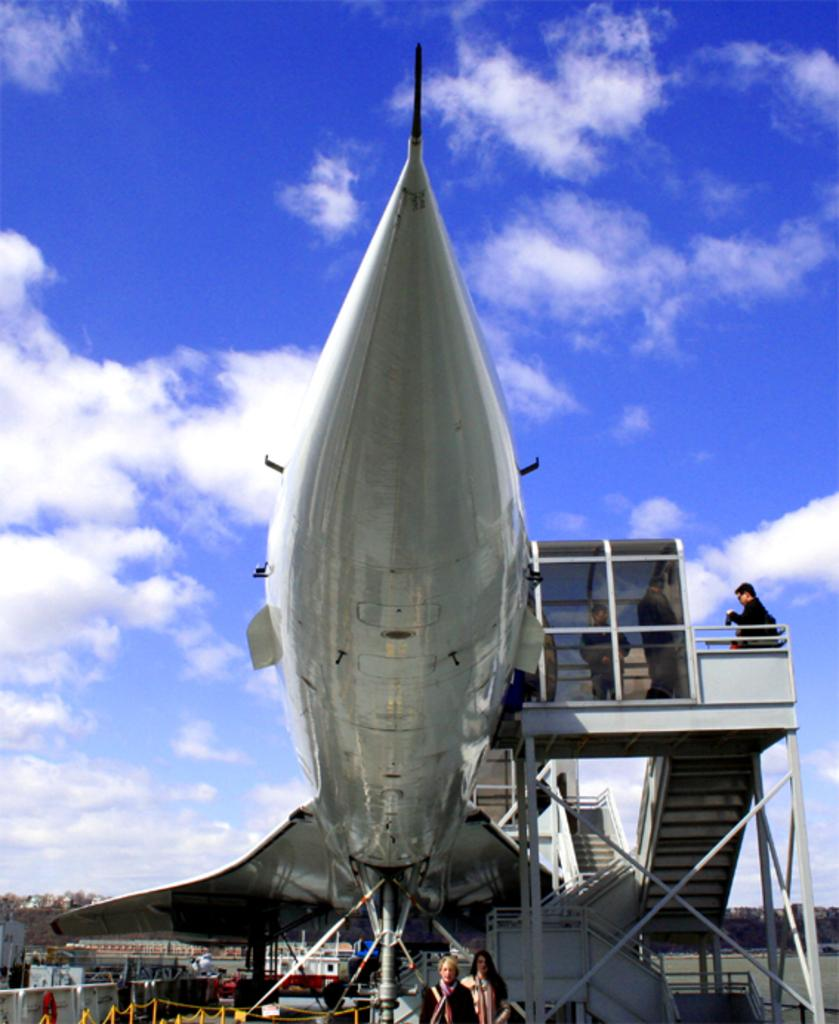What is the main subject of the image? The main subject of the image is a flying jet. What else can be seen in the image besides the jet? There are people wearing clothes, stairs, trees, and a cloudy and blue sky in the image. Can you describe the people in the image? The people in the image are wearing clothes, but their specific clothing or actions are not mentioned in the facts. What is the weather like in the image? The sky is cloudy and blue in the image, which suggests a partly cloudy day. What type of breakfast is being served on the stairs in the image? There is no mention of breakfast or any food items in the image. The image only features a flying jet, people wearing clothes, stairs, trees, and a cloudy and blue sky. 